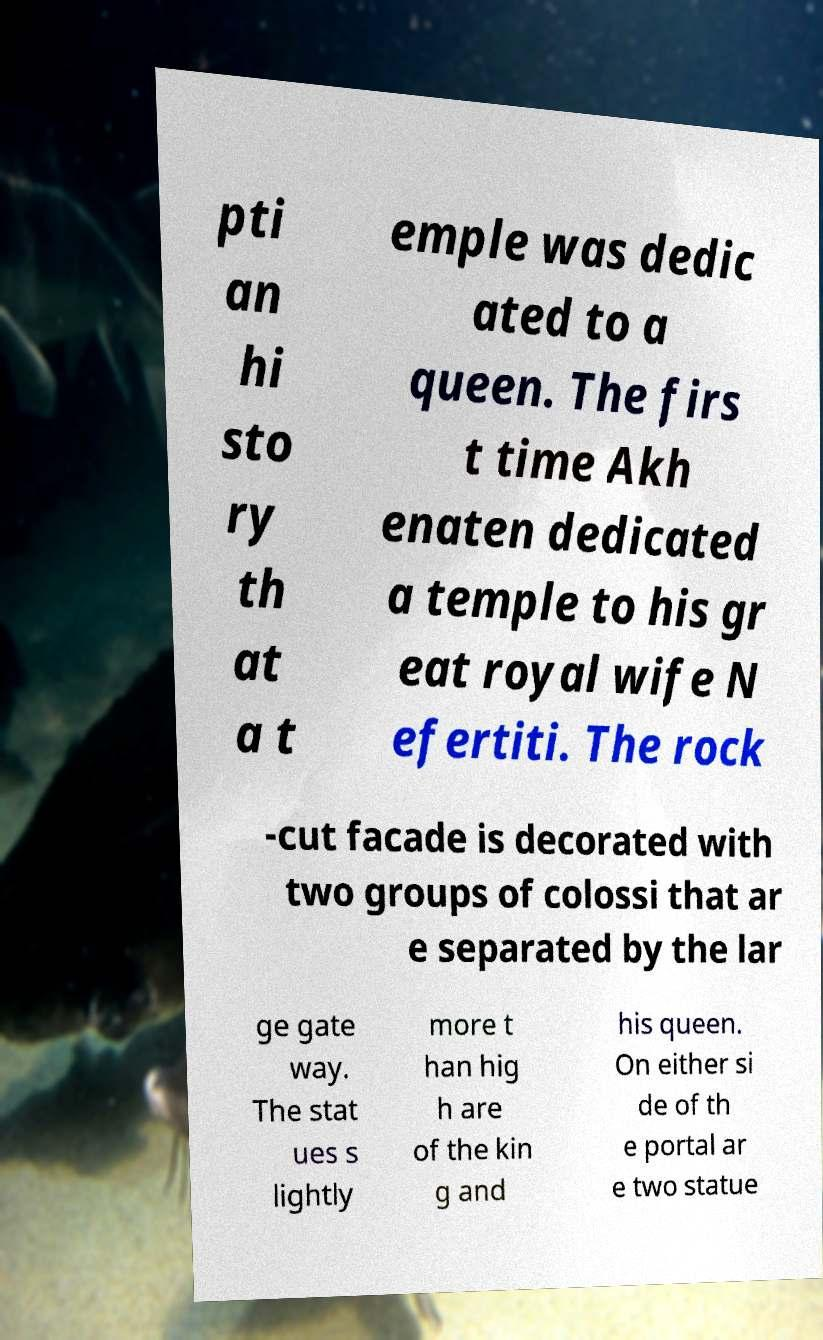Could you extract and type out the text from this image? pti an hi sto ry th at a t emple was dedic ated to a queen. The firs t time Akh enaten dedicated a temple to his gr eat royal wife N efertiti. The rock -cut facade is decorated with two groups of colossi that ar e separated by the lar ge gate way. The stat ues s lightly more t han hig h are of the kin g and his queen. On either si de of th e portal ar e two statue 